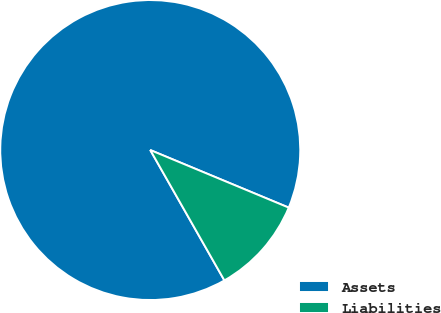<chart> <loc_0><loc_0><loc_500><loc_500><pie_chart><fcel>Assets<fcel>Liabilities<nl><fcel>89.5%<fcel>10.5%<nl></chart> 